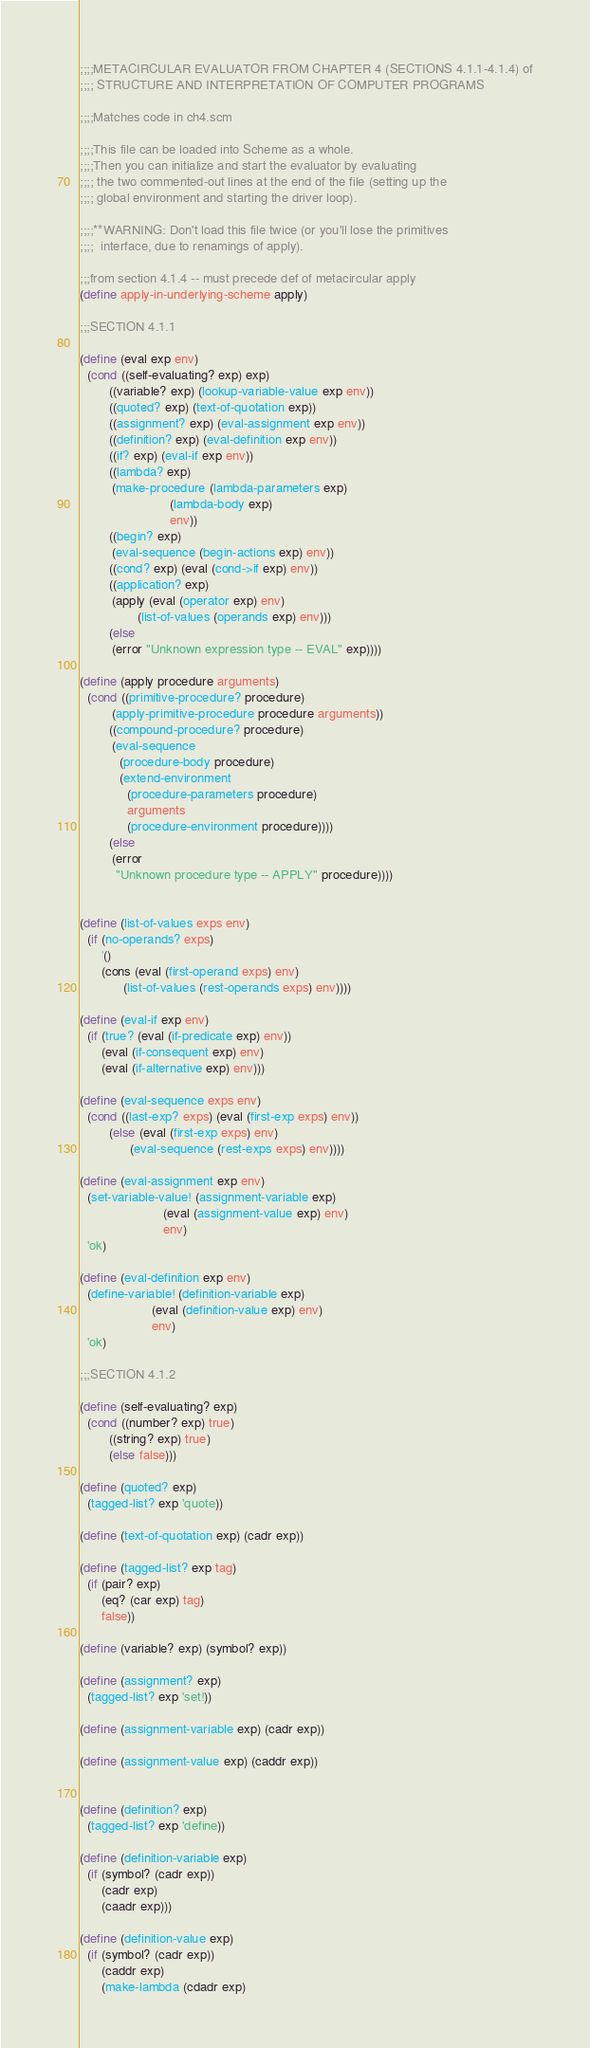Convert code to text. <code><loc_0><loc_0><loc_500><loc_500><_Scheme_>;;;;METACIRCULAR EVALUATOR FROM CHAPTER 4 (SECTIONS 4.1.1-4.1.4) of
;;;; STRUCTURE AND INTERPRETATION OF COMPUTER PROGRAMS

;;;;Matches code in ch4.scm

;;;;This file can be loaded into Scheme as a whole.
;;;;Then you can initialize and start the evaluator by evaluating
;;;; the two commented-out lines at the end of the file (setting up the
;;;; global environment and starting the driver loop).

;;;;**WARNING: Don't load this file twice (or you'll lose the primitives
;;;;  interface, due to renamings of apply).

;;;from section 4.1.4 -- must precede def of metacircular apply
(define apply-in-underlying-scheme apply)

;;;SECTION 4.1.1

(define (eval exp env)
  (cond ((self-evaluating? exp) exp)
        ((variable? exp) (lookup-variable-value exp env))
        ((quoted? exp) (text-of-quotation exp))
        ((assignment? exp) (eval-assignment exp env))
        ((definition? exp) (eval-definition exp env))
        ((if? exp) (eval-if exp env))
        ((lambda? exp)
         (make-procedure (lambda-parameters exp)
                         (lambda-body exp)
                         env))
        ((begin? exp) 
         (eval-sequence (begin-actions exp) env))
        ((cond? exp) (eval (cond->if exp) env))
        ((application? exp)
         (apply (eval (operator exp) env)
                (list-of-values (operands exp) env)))
        (else
         (error "Unknown expression type -- EVAL" exp))))

(define (apply procedure arguments)
  (cond ((primitive-procedure? procedure)
         (apply-primitive-procedure procedure arguments))
        ((compound-procedure? procedure)
         (eval-sequence
           (procedure-body procedure)
           (extend-environment
             (procedure-parameters procedure)
             arguments
             (procedure-environment procedure))))
        (else
         (error
          "Unknown procedure type -- APPLY" procedure))))


(define (list-of-values exps env)
  (if (no-operands? exps)
      '()
      (cons (eval (first-operand exps) env)
            (list-of-values (rest-operands exps) env))))

(define (eval-if exp env)
  (if (true? (eval (if-predicate exp) env))
      (eval (if-consequent exp) env)
      (eval (if-alternative exp) env)))

(define (eval-sequence exps env)
  (cond ((last-exp? exps) (eval (first-exp exps) env))
        (else (eval (first-exp exps) env)
              (eval-sequence (rest-exps exps) env))))

(define (eval-assignment exp env)
  (set-variable-value! (assignment-variable exp)
                       (eval (assignment-value exp) env)
                       env)
  'ok)

(define (eval-definition exp env)
  (define-variable! (definition-variable exp)
                    (eval (definition-value exp) env)
                    env)
  'ok)

;;;SECTION 4.1.2

(define (self-evaluating? exp)
  (cond ((number? exp) true)
        ((string? exp) true)
        (else false)))

(define (quoted? exp)
  (tagged-list? exp 'quote))

(define (text-of-quotation exp) (cadr exp))

(define (tagged-list? exp tag)
  (if (pair? exp)
      (eq? (car exp) tag)
      false))

(define (variable? exp) (symbol? exp))

(define (assignment? exp)
  (tagged-list? exp 'set!))

(define (assignment-variable exp) (cadr exp))

(define (assignment-value exp) (caddr exp))


(define (definition? exp)
  (tagged-list? exp 'define))

(define (definition-variable exp)
  (if (symbol? (cadr exp))
      (cadr exp)
      (caadr exp)))

(define (definition-value exp)
  (if (symbol? (cadr exp))
      (caddr exp)
      (make-lambda (cdadr exp)</code> 